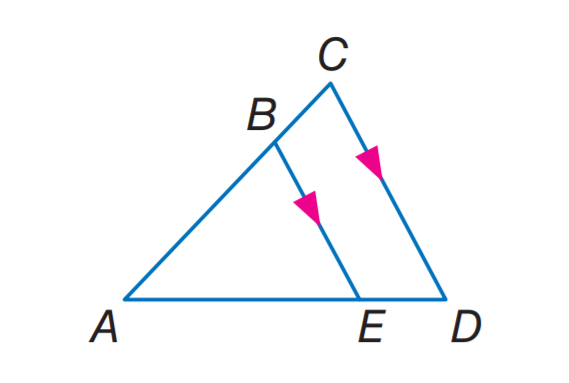Answer the mathemtical geometry problem and directly provide the correct option letter.
Question: If A C = 14, B C = 8, and A D = 21, find E D.
Choices: A: 8 B: 12 C: 14 D: 21 B 